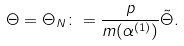Convert formula to latex. <formula><loc_0><loc_0><loc_500><loc_500>\Theta = \Theta _ { N } \colon = \frac { p } { m ( \alpha ^ { ( 1 ) } ) } \tilde { \Theta } .</formula> 